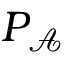<formula> <loc_0><loc_0><loc_500><loc_500>P _ { \mathcal { A } }</formula> 